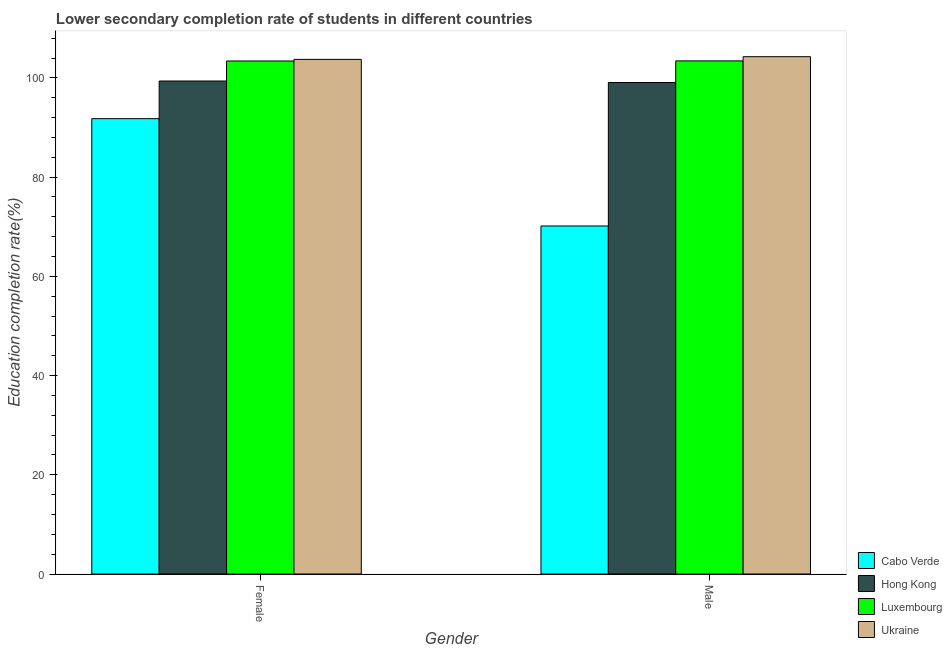How many groups of bars are there?
Your answer should be compact. 2. Are the number of bars on each tick of the X-axis equal?
Provide a succinct answer. Yes. How many bars are there on the 2nd tick from the left?
Offer a very short reply. 4. How many bars are there on the 1st tick from the right?
Make the answer very short. 4. What is the education completion rate of male students in Luxembourg?
Your answer should be compact. 103.43. Across all countries, what is the maximum education completion rate of male students?
Offer a very short reply. 104.28. Across all countries, what is the minimum education completion rate of female students?
Provide a succinct answer. 91.79. In which country was the education completion rate of male students maximum?
Your answer should be very brief. Ukraine. In which country was the education completion rate of female students minimum?
Offer a very short reply. Cabo Verde. What is the total education completion rate of male students in the graph?
Provide a succinct answer. 376.94. What is the difference between the education completion rate of female students in Hong Kong and that in Luxembourg?
Make the answer very short. -4.03. What is the difference between the education completion rate of male students in Hong Kong and the education completion rate of female students in Luxembourg?
Ensure brevity in your answer.  -4.33. What is the average education completion rate of male students per country?
Provide a succinct answer. 94.24. What is the difference between the education completion rate of male students and education completion rate of female students in Ukraine?
Ensure brevity in your answer.  0.54. What is the ratio of the education completion rate of female students in Hong Kong to that in Cabo Verde?
Make the answer very short. 1.08. Is the education completion rate of female students in Ukraine less than that in Cabo Verde?
Offer a very short reply. No. What does the 1st bar from the left in Male represents?
Ensure brevity in your answer.  Cabo Verde. What does the 4th bar from the right in Female represents?
Your response must be concise. Cabo Verde. How many legend labels are there?
Your response must be concise. 4. What is the title of the graph?
Your response must be concise. Lower secondary completion rate of students in different countries. Does "Montenegro" appear as one of the legend labels in the graph?
Provide a succinct answer. No. What is the label or title of the Y-axis?
Keep it short and to the point. Education completion rate(%). What is the Education completion rate(%) of Cabo Verde in Female?
Your answer should be very brief. 91.79. What is the Education completion rate(%) of Hong Kong in Female?
Keep it short and to the point. 99.38. What is the Education completion rate(%) in Luxembourg in Female?
Ensure brevity in your answer.  103.41. What is the Education completion rate(%) of Ukraine in Female?
Keep it short and to the point. 103.74. What is the Education completion rate(%) of Cabo Verde in Male?
Your answer should be compact. 70.15. What is the Education completion rate(%) of Hong Kong in Male?
Make the answer very short. 99.08. What is the Education completion rate(%) in Luxembourg in Male?
Your answer should be very brief. 103.43. What is the Education completion rate(%) in Ukraine in Male?
Provide a short and direct response. 104.28. Across all Gender, what is the maximum Education completion rate(%) of Cabo Verde?
Offer a very short reply. 91.79. Across all Gender, what is the maximum Education completion rate(%) of Hong Kong?
Offer a very short reply. 99.38. Across all Gender, what is the maximum Education completion rate(%) in Luxembourg?
Give a very brief answer. 103.43. Across all Gender, what is the maximum Education completion rate(%) in Ukraine?
Your response must be concise. 104.28. Across all Gender, what is the minimum Education completion rate(%) of Cabo Verde?
Your answer should be very brief. 70.15. Across all Gender, what is the minimum Education completion rate(%) of Hong Kong?
Offer a terse response. 99.08. Across all Gender, what is the minimum Education completion rate(%) of Luxembourg?
Provide a short and direct response. 103.41. Across all Gender, what is the minimum Education completion rate(%) in Ukraine?
Your answer should be very brief. 103.74. What is the total Education completion rate(%) of Cabo Verde in the graph?
Give a very brief answer. 161.94. What is the total Education completion rate(%) in Hong Kong in the graph?
Make the answer very short. 198.45. What is the total Education completion rate(%) in Luxembourg in the graph?
Ensure brevity in your answer.  206.84. What is the total Education completion rate(%) of Ukraine in the graph?
Offer a very short reply. 208.01. What is the difference between the Education completion rate(%) of Cabo Verde in Female and that in Male?
Provide a succinct answer. 21.63. What is the difference between the Education completion rate(%) of Hong Kong in Female and that in Male?
Offer a very short reply. 0.3. What is the difference between the Education completion rate(%) in Luxembourg in Female and that in Male?
Give a very brief answer. -0.02. What is the difference between the Education completion rate(%) in Ukraine in Female and that in Male?
Keep it short and to the point. -0.54. What is the difference between the Education completion rate(%) in Cabo Verde in Female and the Education completion rate(%) in Hong Kong in Male?
Offer a terse response. -7.29. What is the difference between the Education completion rate(%) of Cabo Verde in Female and the Education completion rate(%) of Luxembourg in Male?
Provide a short and direct response. -11.65. What is the difference between the Education completion rate(%) of Cabo Verde in Female and the Education completion rate(%) of Ukraine in Male?
Keep it short and to the point. -12.49. What is the difference between the Education completion rate(%) of Hong Kong in Female and the Education completion rate(%) of Luxembourg in Male?
Give a very brief answer. -4.06. What is the difference between the Education completion rate(%) of Hong Kong in Female and the Education completion rate(%) of Ukraine in Male?
Provide a short and direct response. -4.9. What is the difference between the Education completion rate(%) in Luxembourg in Female and the Education completion rate(%) in Ukraine in Male?
Your response must be concise. -0.87. What is the average Education completion rate(%) in Cabo Verde per Gender?
Keep it short and to the point. 80.97. What is the average Education completion rate(%) in Hong Kong per Gender?
Provide a succinct answer. 99.23. What is the average Education completion rate(%) in Luxembourg per Gender?
Ensure brevity in your answer.  103.42. What is the average Education completion rate(%) of Ukraine per Gender?
Your answer should be very brief. 104.01. What is the difference between the Education completion rate(%) in Cabo Verde and Education completion rate(%) in Hong Kong in Female?
Your answer should be compact. -7.59. What is the difference between the Education completion rate(%) in Cabo Verde and Education completion rate(%) in Luxembourg in Female?
Provide a short and direct response. -11.62. What is the difference between the Education completion rate(%) of Cabo Verde and Education completion rate(%) of Ukraine in Female?
Make the answer very short. -11.95. What is the difference between the Education completion rate(%) in Hong Kong and Education completion rate(%) in Luxembourg in Female?
Give a very brief answer. -4.03. What is the difference between the Education completion rate(%) in Hong Kong and Education completion rate(%) in Ukraine in Female?
Your response must be concise. -4.36. What is the difference between the Education completion rate(%) of Luxembourg and Education completion rate(%) of Ukraine in Female?
Offer a very short reply. -0.33. What is the difference between the Education completion rate(%) in Cabo Verde and Education completion rate(%) in Hong Kong in Male?
Make the answer very short. -28.92. What is the difference between the Education completion rate(%) of Cabo Verde and Education completion rate(%) of Luxembourg in Male?
Your answer should be compact. -33.28. What is the difference between the Education completion rate(%) in Cabo Verde and Education completion rate(%) in Ukraine in Male?
Your response must be concise. -34.12. What is the difference between the Education completion rate(%) in Hong Kong and Education completion rate(%) in Luxembourg in Male?
Provide a succinct answer. -4.35. What is the difference between the Education completion rate(%) in Hong Kong and Education completion rate(%) in Ukraine in Male?
Provide a short and direct response. -5.2. What is the difference between the Education completion rate(%) in Luxembourg and Education completion rate(%) in Ukraine in Male?
Give a very brief answer. -0.84. What is the ratio of the Education completion rate(%) in Cabo Verde in Female to that in Male?
Give a very brief answer. 1.31. What is the ratio of the Education completion rate(%) of Hong Kong in Female to that in Male?
Your answer should be compact. 1. What is the ratio of the Education completion rate(%) of Luxembourg in Female to that in Male?
Keep it short and to the point. 1. What is the difference between the highest and the second highest Education completion rate(%) of Cabo Verde?
Offer a very short reply. 21.63. What is the difference between the highest and the second highest Education completion rate(%) of Hong Kong?
Keep it short and to the point. 0.3. What is the difference between the highest and the second highest Education completion rate(%) of Luxembourg?
Give a very brief answer. 0.02. What is the difference between the highest and the second highest Education completion rate(%) in Ukraine?
Make the answer very short. 0.54. What is the difference between the highest and the lowest Education completion rate(%) of Cabo Verde?
Your answer should be very brief. 21.63. What is the difference between the highest and the lowest Education completion rate(%) in Hong Kong?
Provide a short and direct response. 0.3. What is the difference between the highest and the lowest Education completion rate(%) of Luxembourg?
Make the answer very short. 0.02. What is the difference between the highest and the lowest Education completion rate(%) of Ukraine?
Your answer should be very brief. 0.54. 